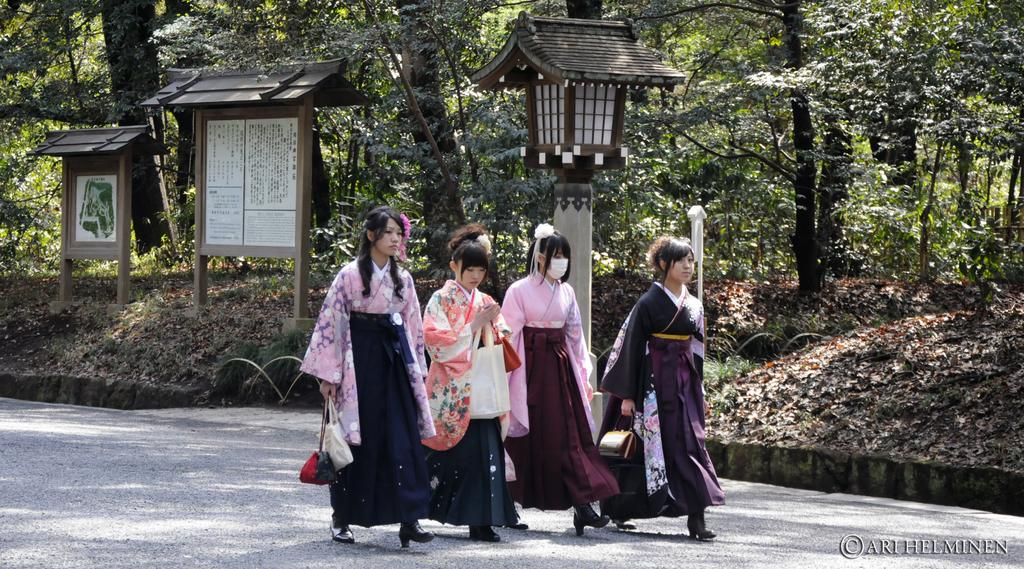What are the women in the image doing? The women in the image are walking on the road. What are the people holding in the image? The people in the image are holding bags. What can be seen in the background of the image? There are sign boards and trees in the background. What type of frame is used to hold the card in the image? There is no card or frame present in the image. How many bananas can be seen in the image? There are no bananas present in the image. 